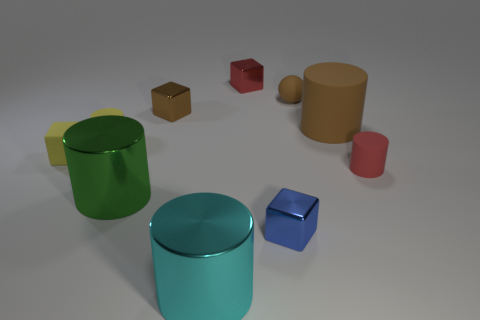Subtract all large brown rubber cylinders. How many cylinders are left? 4 Subtract all cyan cylinders. How many cylinders are left? 4 Subtract 1 cylinders. How many cylinders are left? 4 Subtract all purple cylinders. Subtract all red cubes. How many cylinders are left? 5 Subtract all spheres. How many objects are left? 9 Subtract 1 yellow blocks. How many objects are left? 9 Subtract all tiny brown matte cylinders. Subtract all big metal things. How many objects are left? 8 Add 2 large shiny cylinders. How many large shiny cylinders are left? 4 Add 3 small cubes. How many small cubes exist? 7 